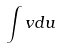Convert formula to latex. <formula><loc_0><loc_0><loc_500><loc_500>\int v d u</formula> 